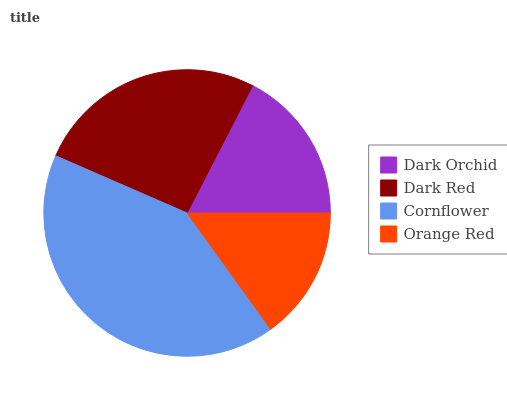Is Orange Red the minimum?
Answer yes or no. Yes. Is Cornflower the maximum?
Answer yes or no. Yes. Is Dark Red the minimum?
Answer yes or no. No. Is Dark Red the maximum?
Answer yes or no. No. Is Dark Red greater than Dark Orchid?
Answer yes or no. Yes. Is Dark Orchid less than Dark Red?
Answer yes or no. Yes. Is Dark Orchid greater than Dark Red?
Answer yes or no. No. Is Dark Red less than Dark Orchid?
Answer yes or no. No. Is Dark Red the high median?
Answer yes or no. Yes. Is Dark Orchid the low median?
Answer yes or no. Yes. Is Dark Orchid the high median?
Answer yes or no. No. Is Cornflower the low median?
Answer yes or no. No. 